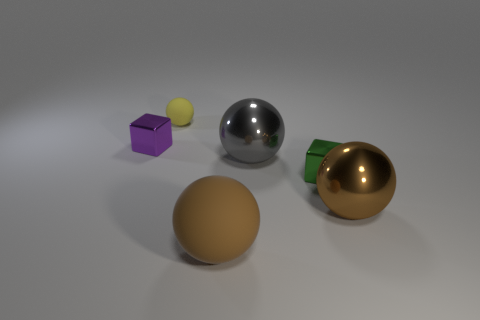What is the green object made of? The green object appears to be the lid of a spherical container and seems to be made of a polished metal, likely aluminum or steel, which is commonly used for such items due to its durability and lustrous finish. 